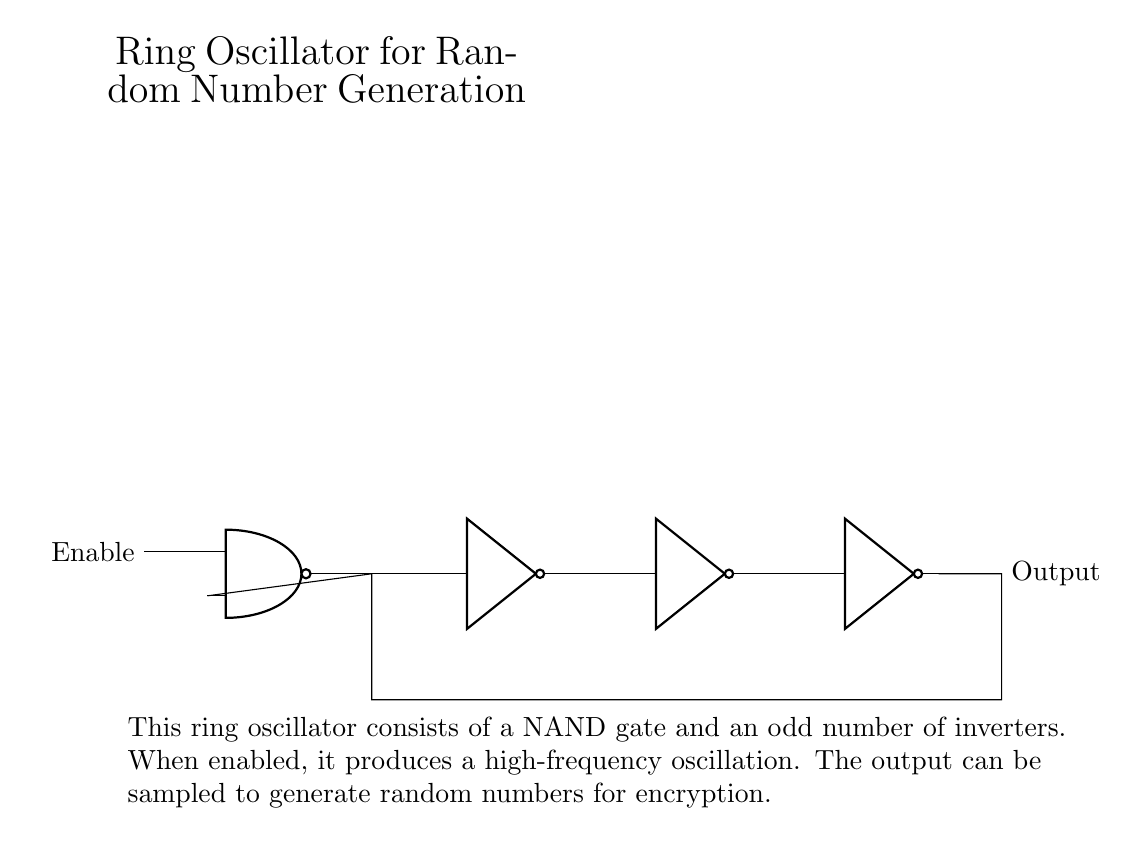What type of gate is used as the main component? The main component is a NAND gate, which is indicated at the beginning of the circuit diagram.
Answer: NAND gate How many NOT gates are present in the circuit? There are three NOT gates in the circuit, as counted along the bottom section of the diagram.
Answer: Three What is the output of the oscillator? The output is located on the right side of the circuit diagram, labeled as "Output".
Answer: Output What is the role of the Enable input? The Enable input allows the oscillator to be activated, controlling whether the NAND gate can produce oscillations.
Answer: Activates oscillation Why is an odd number of inverters used in the ring oscillator? An odd number of inverters ensures that the feedback loop creates a positive feedback condition, allowing the circuit to oscillate.
Answer: To ensure oscillation What happens when the oscillator is enabled? When enabled, the circuit produces a high-frequency oscillation, demonstrated by the connections leading to the output node.
Answer: Produces oscillation What type of circuit is this described as? The circuit is described as a ring oscillator used for generating random numbers in encryption systems, which is highlighted in the explanation below the circuit diagram.
Answer: Ring oscillator 